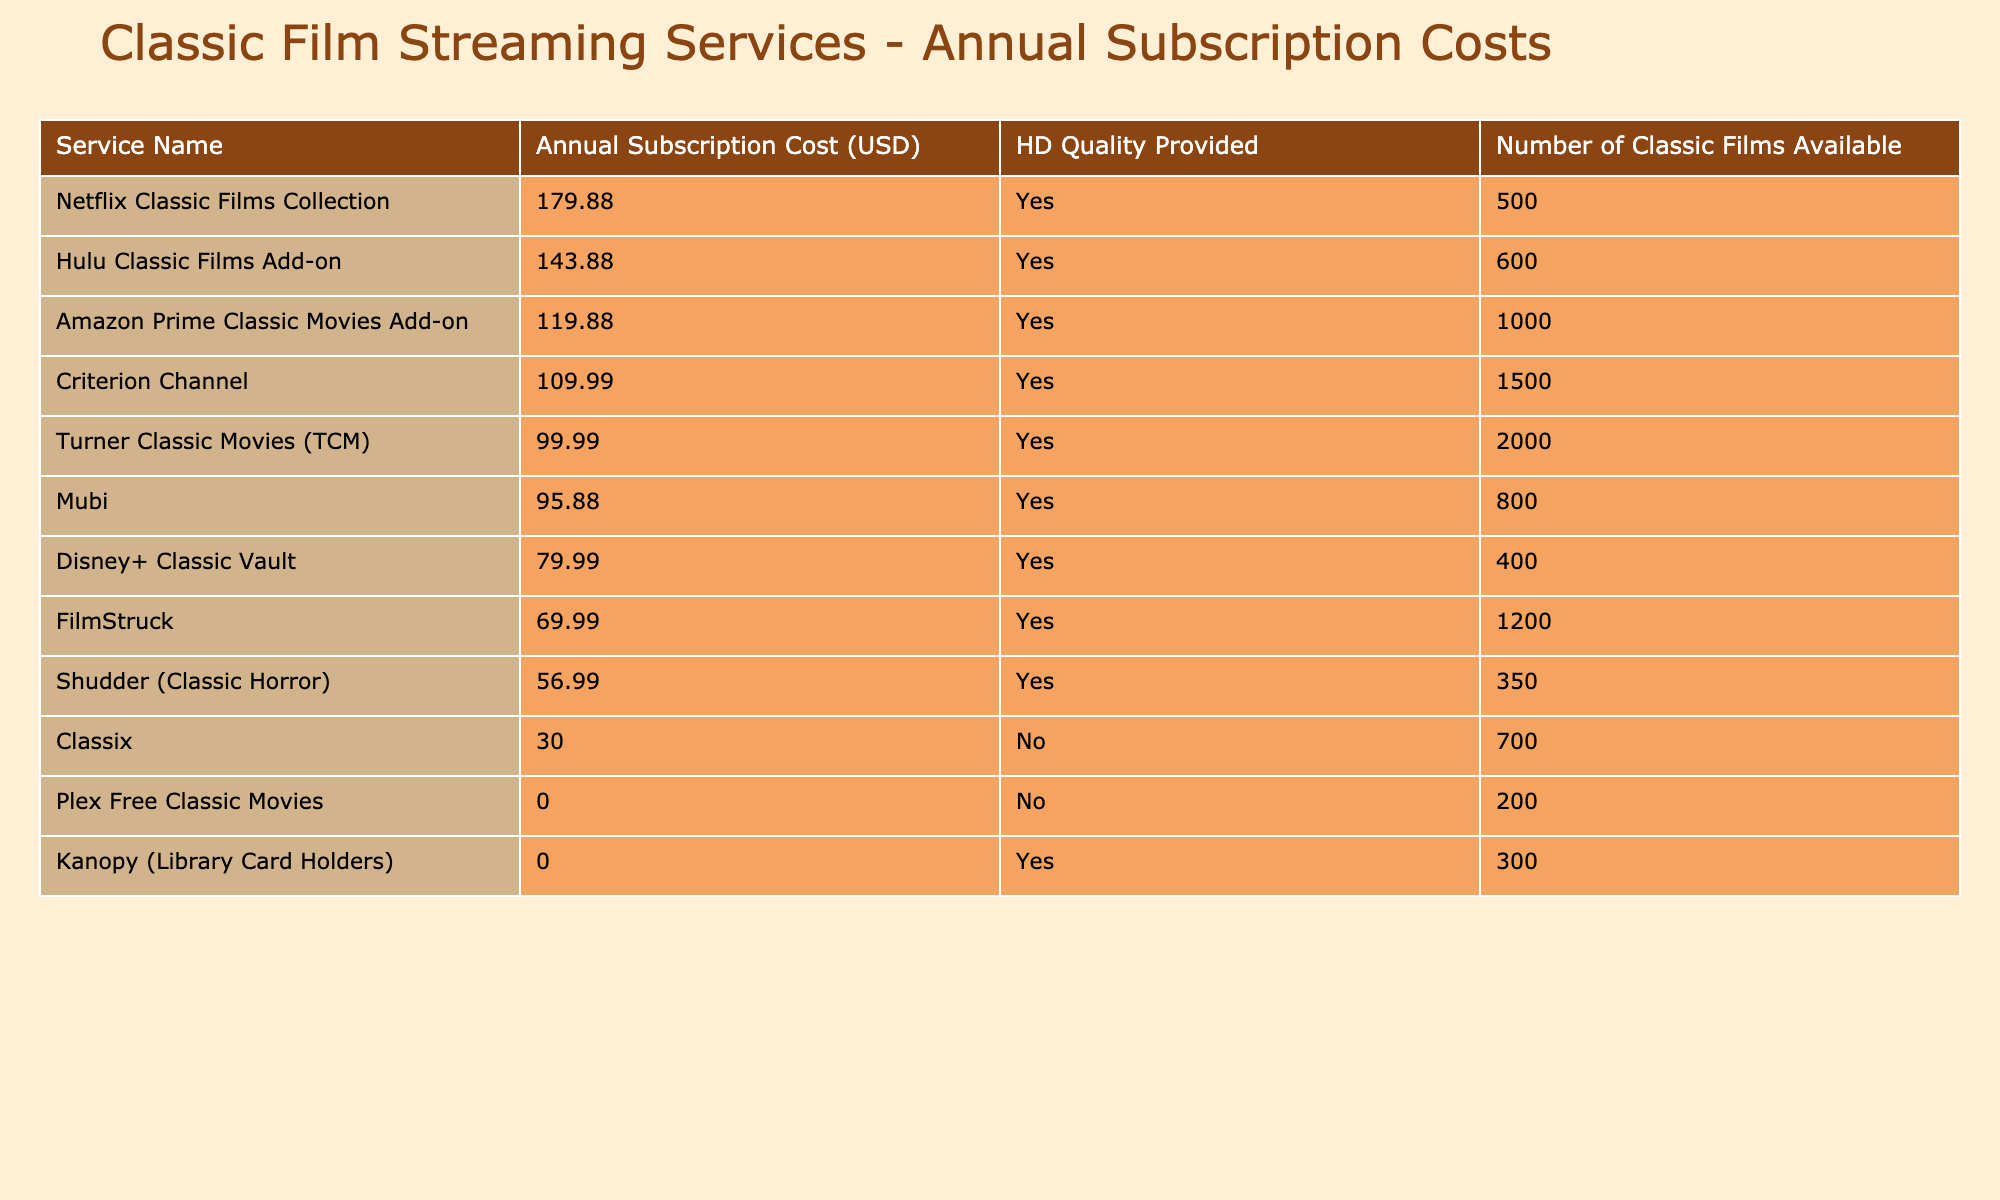What is the annual subscription cost of the Criterion Channel? The table lists the annual subscription cost for the Criterion Channel as 109.99 USD.
Answer: 109.99 USD How many classic films are available on Turner Classic Movies? According to the table, Turner Classic Movies has 2000 classic films available.
Answer: 2000 Which service has the lowest annual subscription cost? By looking through the table, Plex Free Classic Movies has an annual subscription cost of 0.00 USD, making it the lowest.
Answer: 0.00 USD What is the total annual subscription cost for the top three most expensive services? The top three most expensive services are Netflix Classic Films Collection (179.88 USD), Amazon Prime Classic Movies Add-on (119.88 USD), and Hulu Classic Films Add-on (143.88 USD). Summing these gives: 179.88 + 119.88 + 143.88 = 443.64 USD.
Answer: 443.64 USD How many total classic films are available among all services that provide HD quality? The services providing HD quality are Criterion Channel (1500), Turner Classic Movies (2000), Mubi (800), FilmStruck (1200), Shudder (Classic Horror) (350), Netflix Classic Films Collection (500), Amazon Prime Classic Movies Add-on (1000), and Hulu Classic Films Add-on (600). Summing these gives: 1500 + 2000 + 800 + 1200 + 350 + 500 + 1000 + 600 = 7050 classic films available in HD quality.
Answer: 7050 Is Classix providing HD quality for its films? According to the table, Classix is marked as "No" for HD quality, meaning it does not provide HD quality for its films.
Answer: No 